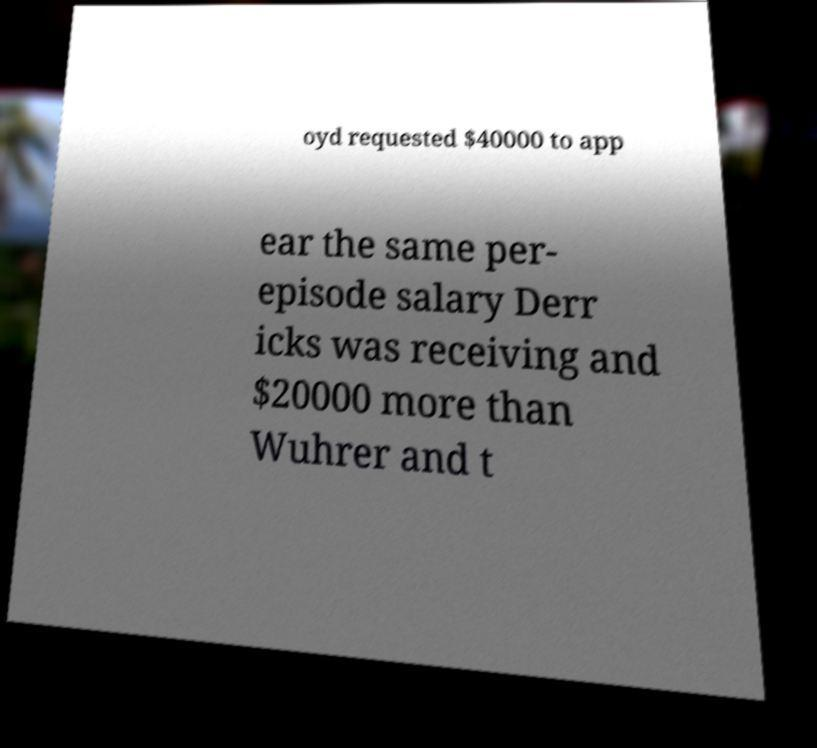There's text embedded in this image that I need extracted. Can you transcribe it verbatim? oyd requested $40000 to app ear the same per- episode salary Derr icks was receiving and $20000 more than Wuhrer and t 